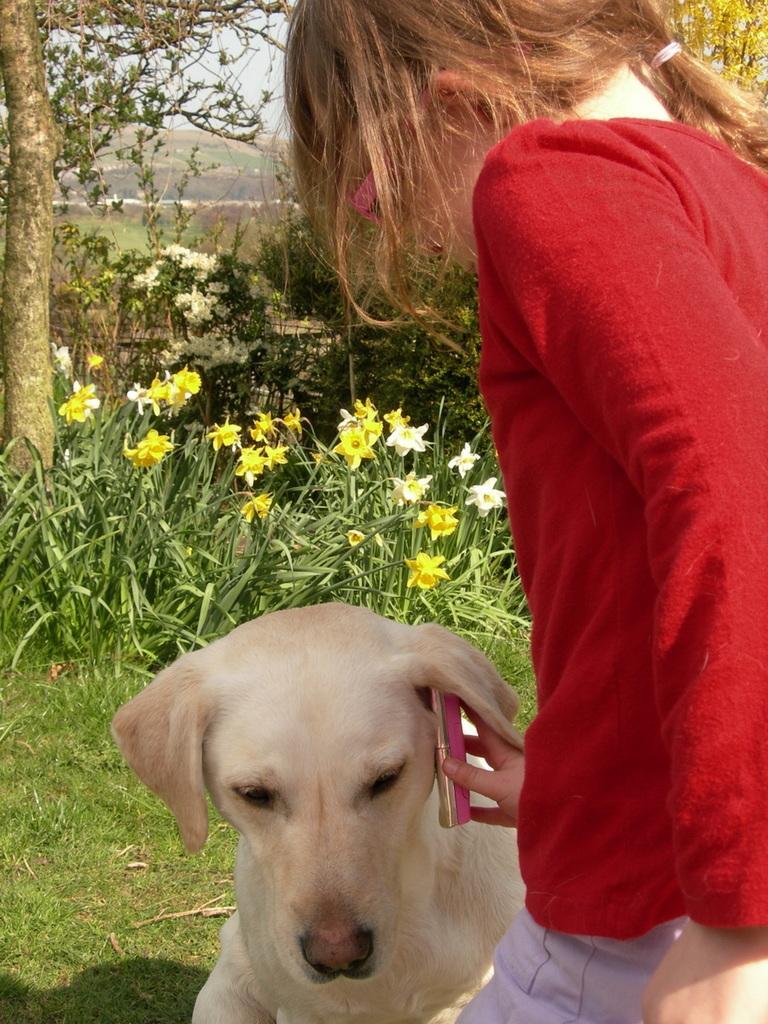Could you give a brief overview of what you see in this image? This picture consists of a dog and a girl holding mobile in her hand. In the background there are plants and flowers. On the top left there is a tree. On the top we can see hills and sky. 